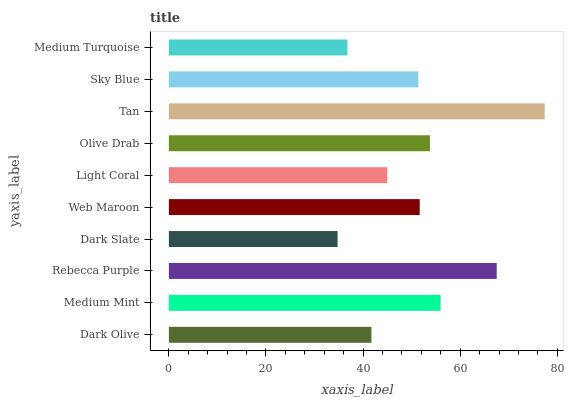Is Dark Slate the minimum?
Answer yes or no. Yes. Is Tan the maximum?
Answer yes or no. Yes. Is Medium Mint the minimum?
Answer yes or no. No. Is Medium Mint the maximum?
Answer yes or no. No. Is Medium Mint greater than Dark Olive?
Answer yes or no. Yes. Is Dark Olive less than Medium Mint?
Answer yes or no. Yes. Is Dark Olive greater than Medium Mint?
Answer yes or no. No. Is Medium Mint less than Dark Olive?
Answer yes or no. No. Is Web Maroon the high median?
Answer yes or no. Yes. Is Sky Blue the low median?
Answer yes or no. Yes. Is Olive Drab the high median?
Answer yes or no. No. Is Olive Drab the low median?
Answer yes or no. No. 